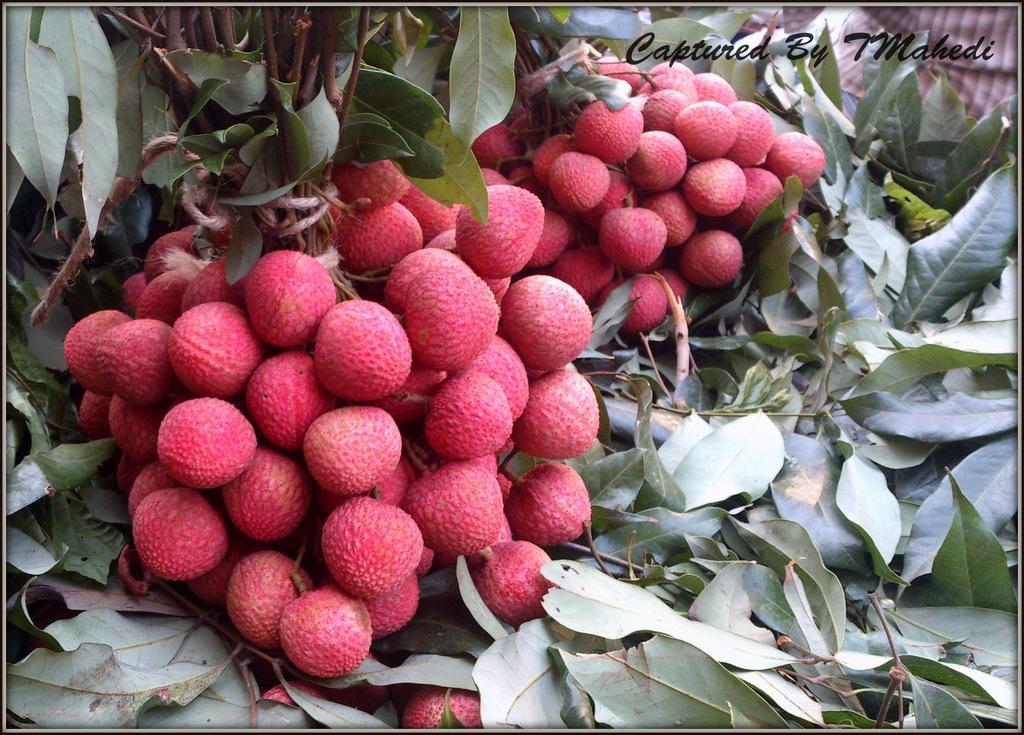What type of fruit is shown in the image? There are bunches of litchi in the image. What else can be seen in the image besides the litchi? There are leaves visible in the image. Is there any text or logo present in the image? Yes, there is a watermark in the right top corner of the image. Can you see a swing in the image? No, there is no swing present in the image. What stage of development is the roof in the image? There is no roof present in the image, so it is not possible to determine its stage of development. 